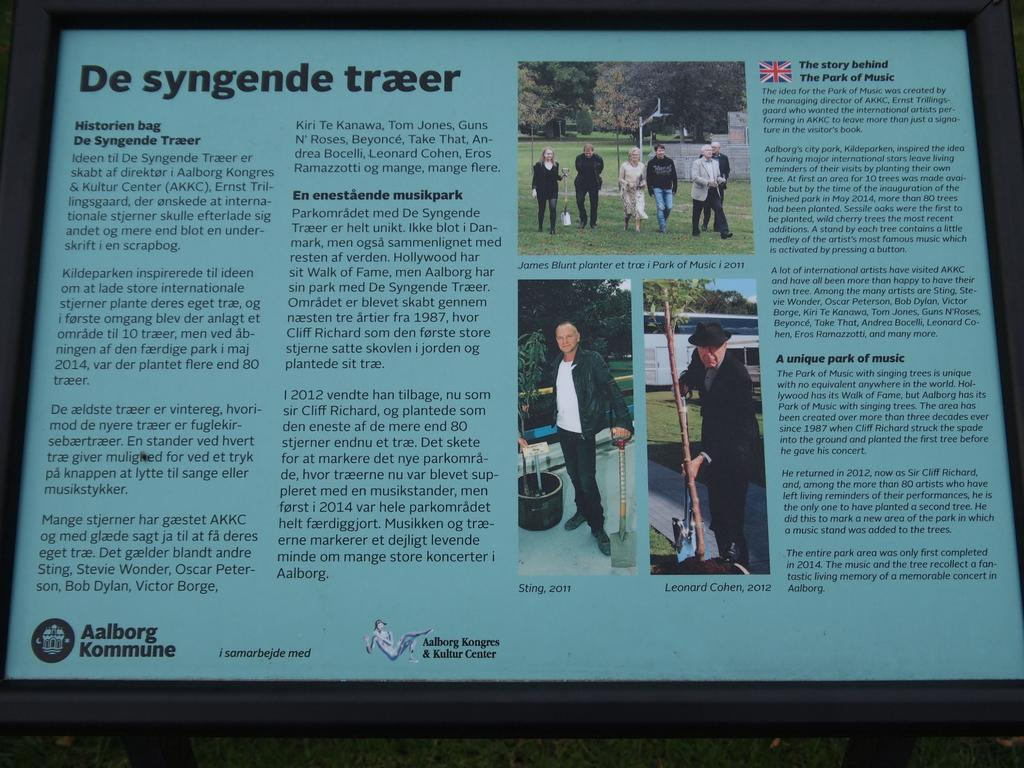<image>
Render a clear and concise summary of the photo. A plaque shows images and information titled De syngende traeer. 